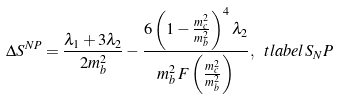Convert formula to latex. <formula><loc_0><loc_0><loc_500><loc_500>\Delta S ^ { N P } = \frac { \lambda _ { 1 } + 3 \lambda _ { 2 } } { 2 m _ { b } ^ { 2 } } - \frac { 6 \left ( 1 - \frac { m _ { c } ^ { 2 } } { m _ { b } ^ { 2 } } \right ) ^ { 4 } \lambda _ { 2 } } { m _ { b } ^ { 2 } \, F \left ( \frac { m _ { c } ^ { 2 } } { m _ { b } ^ { 2 } } \right ) } , \ t l a b e l { S _ { N } P }</formula> 